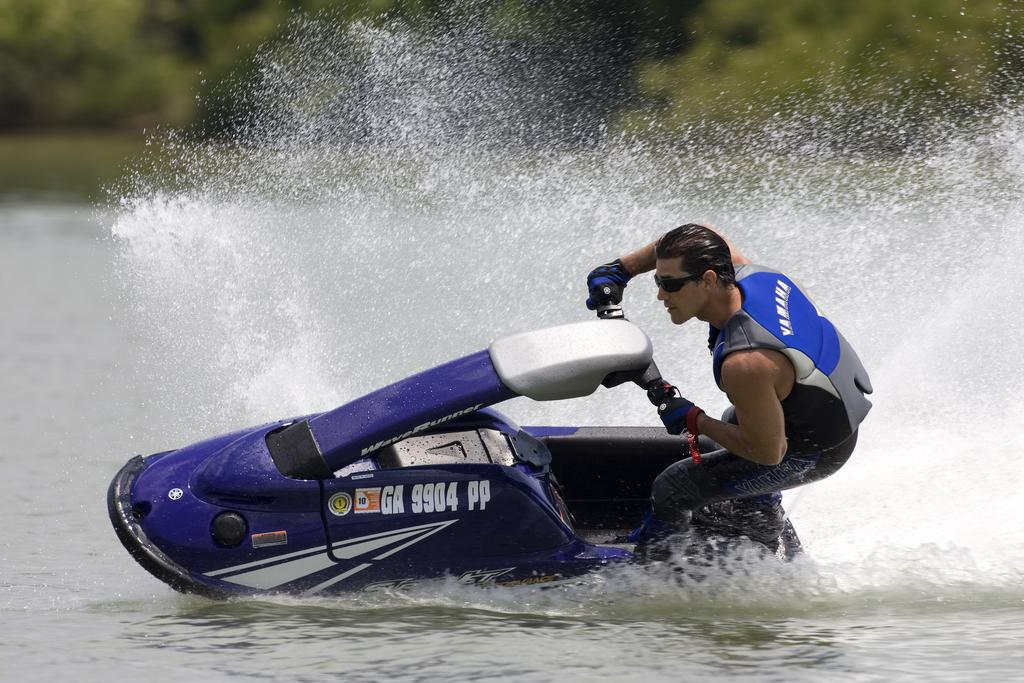Who is the main subject in the image? There is a person in the image. What is the person doing in the image? The person is riding a boat. What type of vehicle is the person using? The boat is a watercraft. Can you describe the background of the image? The background of the image is blurry. What type of root can be seen growing from the person's heart in the image? There is no root or reference to a person's heart in the image; it features a person riding a boat with a blurry background. 